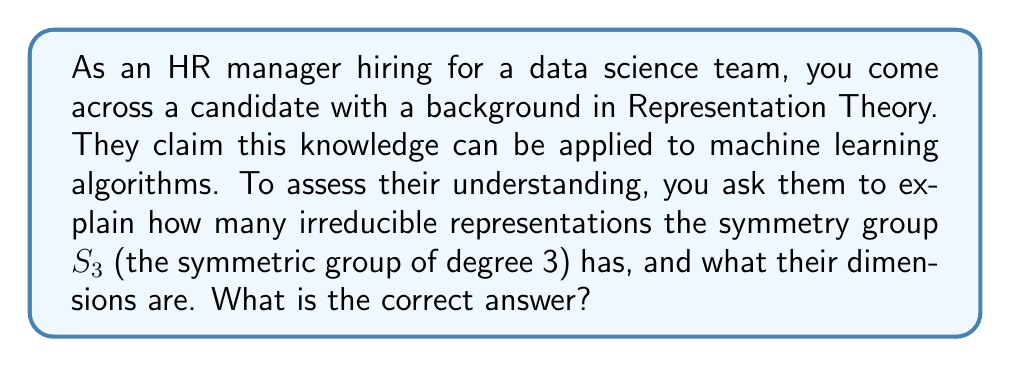Teach me how to tackle this problem. To answer this question, we need to analyze the symmetry group $S_3$ and its irreducible representations:

1. First, recall that $S_3$ is the group of all permutations on 3 elements. It has 6 elements in total.

2. The number of irreducible representations of a finite group is equal to the number of conjugacy classes in the group. For $S_3$, we have 3 conjugacy classes:
   - The identity element: $\{e\}$
   - The 3 transpositions: $\{(12), (13), (23)\}$
   - The 2 3-cycles: $\{(123), (132)\}$

3. Therefore, $S_3$ has 3 irreducible representations.

4. To find the dimensions of these representations, we can use the fact that the sum of the squares of the dimensions of irreducible representations must equal the order of the group:

   $$d_1^2 + d_2^2 + d_3^2 = |S_3| = 6$$

5. We know that every group has a 1-dimensional trivial representation. So $d_1 = 1$.

6. The remaining two dimensions must satisfy:
   $$1^2 + d_2^2 + d_3^2 = 6$$
   $$d_2^2 + d_3^2 = 5$$

7. The only integer solution to this equation is $d_2 = 1$ and $d_3 = 2$.

Therefore, $S_3$ has three irreducible representations: two of dimension 1 and one of dimension 2.
Answer: 3 irreducible representations: two 1-dimensional and one 2-dimensional 